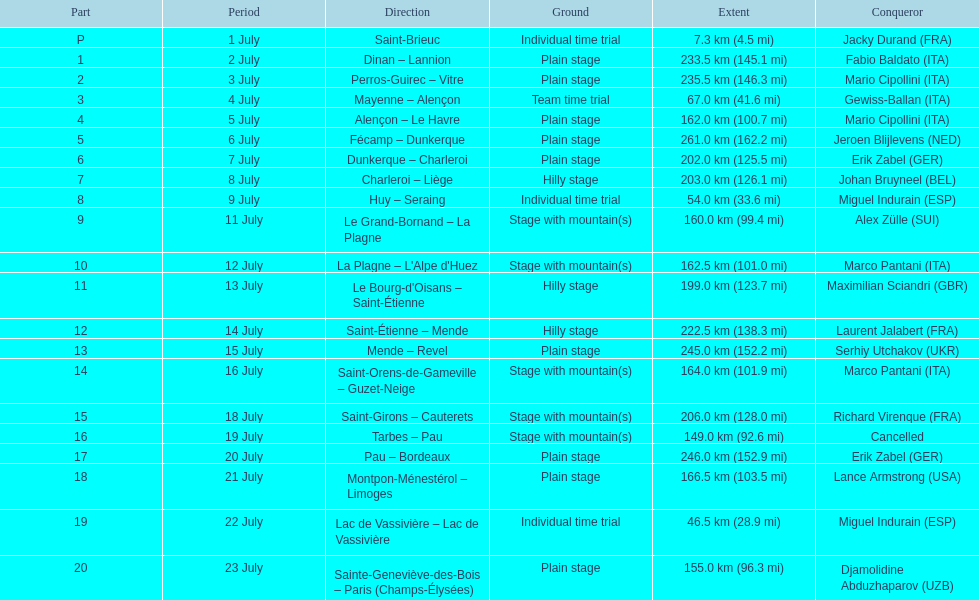Which routes were at least 100 km? Dinan - Lannion, Perros-Guirec - Vitre, Alençon - Le Havre, Fécamp - Dunkerque, Dunkerque - Charleroi, Charleroi - Liège, Le Grand-Bornand - La Plagne, La Plagne - L'Alpe d'Huez, Le Bourg-d'Oisans - Saint-Étienne, Saint-Étienne - Mende, Mende - Revel, Saint-Orens-de-Gameville - Guzet-Neige, Saint-Girons - Cauterets, Tarbes - Pau, Pau - Bordeaux, Montpon-Ménestérol - Limoges, Sainte-Geneviève-des-Bois - Paris (Champs-Élysées). 